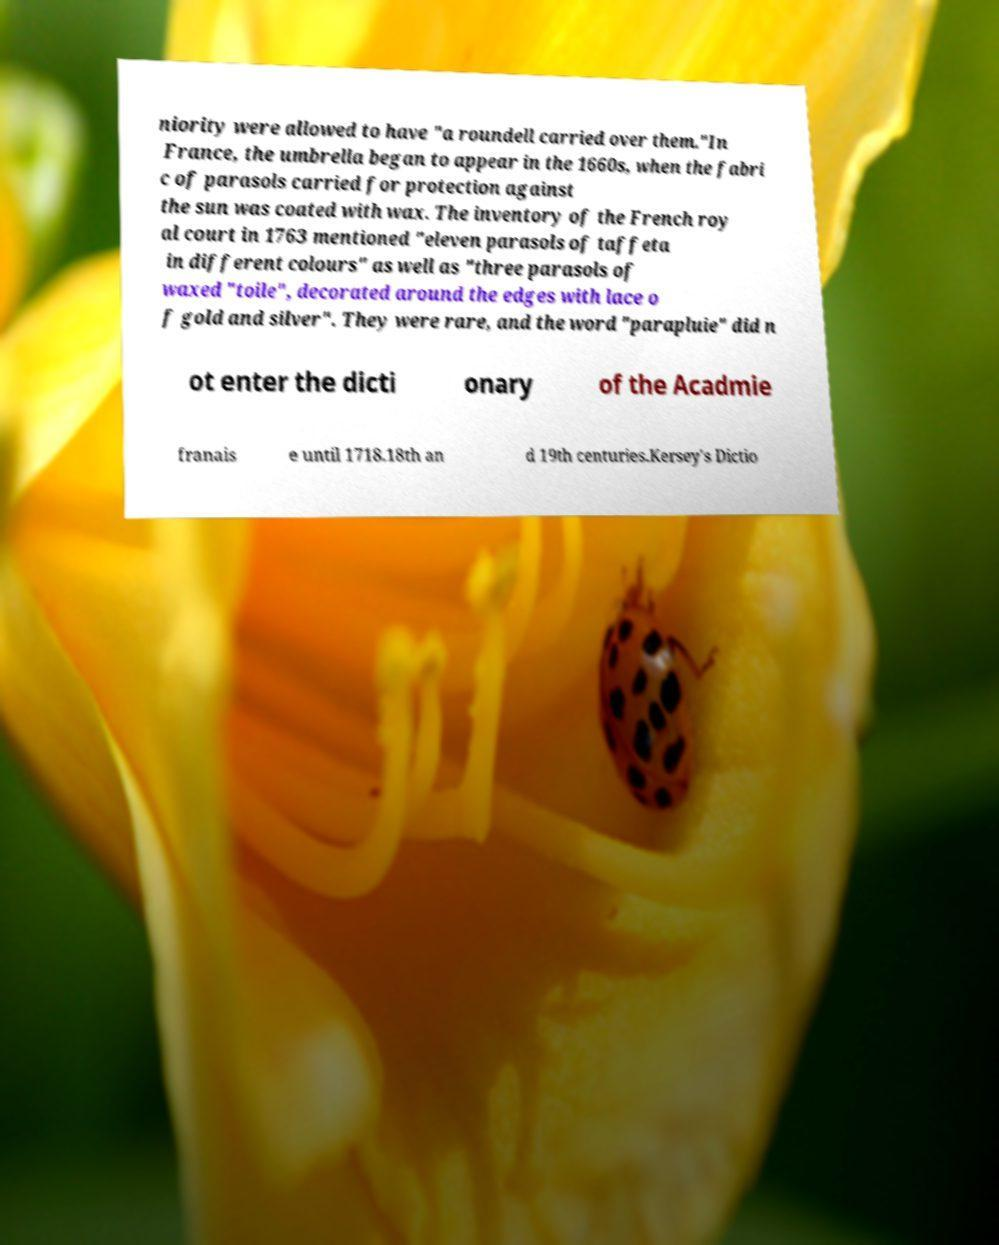I need the written content from this picture converted into text. Can you do that? niority were allowed to have "a roundell carried over them."In France, the umbrella began to appear in the 1660s, when the fabri c of parasols carried for protection against the sun was coated with wax. The inventory of the French roy al court in 1763 mentioned "eleven parasols of taffeta in different colours" as well as "three parasols of waxed "toile", decorated around the edges with lace o f gold and silver". They were rare, and the word "parapluie" did n ot enter the dicti onary of the Acadmie franais e until 1718.18th an d 19th centuries.Kersey's Dictio 